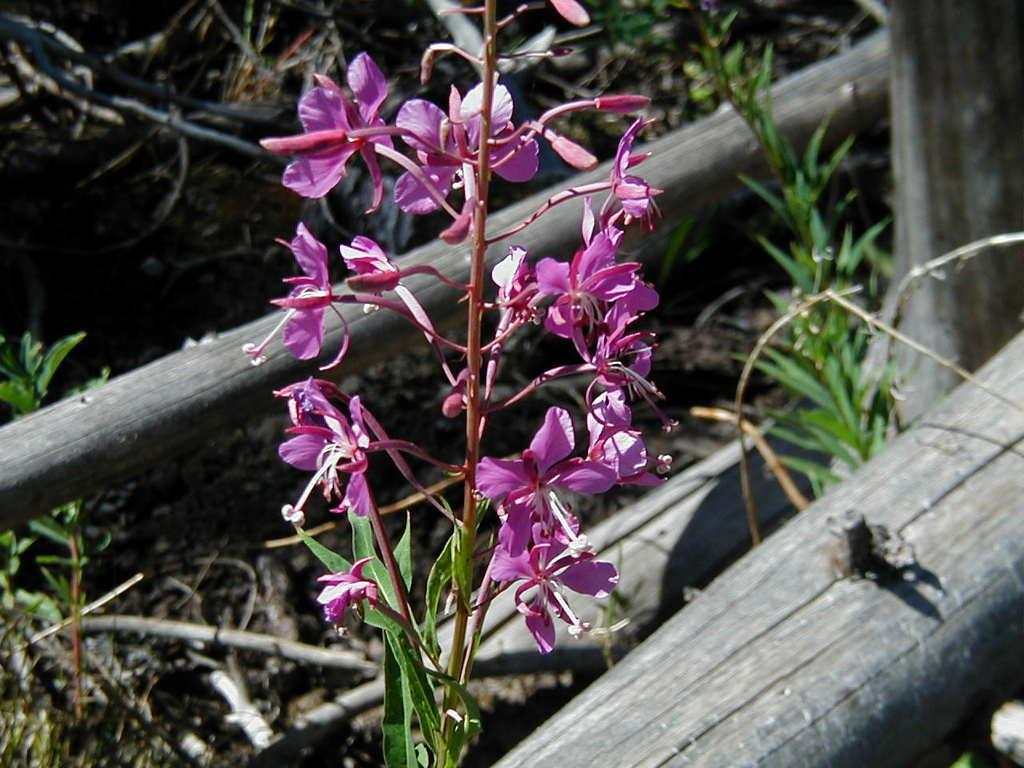What type of living organisms can be seen in the image? Flowers and plants can be seen in the image. What material are the poles made of in the image? The poles in the image are made of wood. Do the flowers have tails in the image? No, flowers do not have tails, so they cannot be seen in the image. What type of education is being provided in the image? There is no indication of any educational activity in the image. 